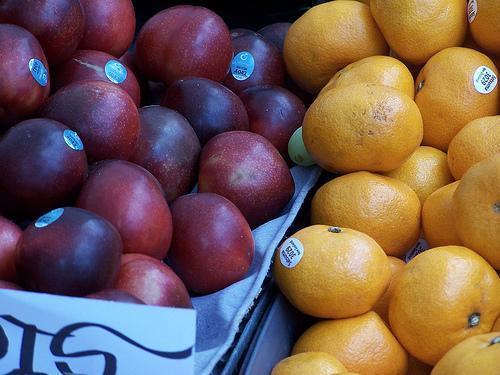How many grapes are in the picture?
Give a very brief answer. 1. 